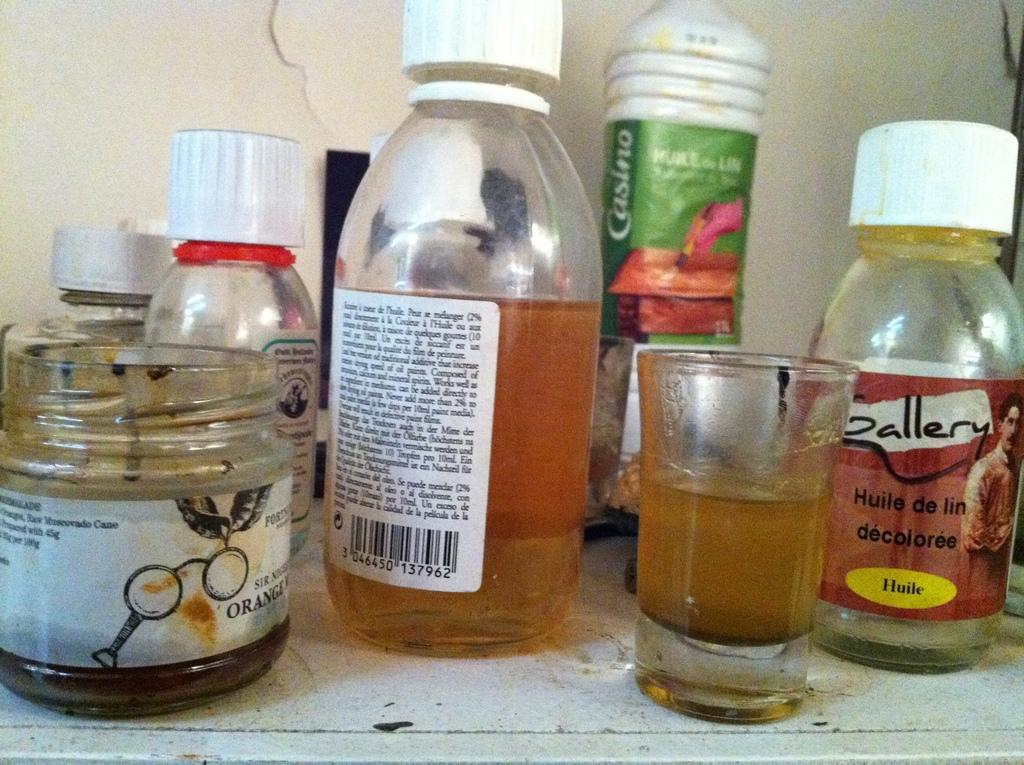<image>
Write a terse but informative summary of the picture. Some bottles on a shelf including one by Gallery Huile de lin decoloree. 